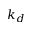Convert formula to latex. <formula><loc_0><loc_0><loc_500><loc_500>k _ { d }</formula> 